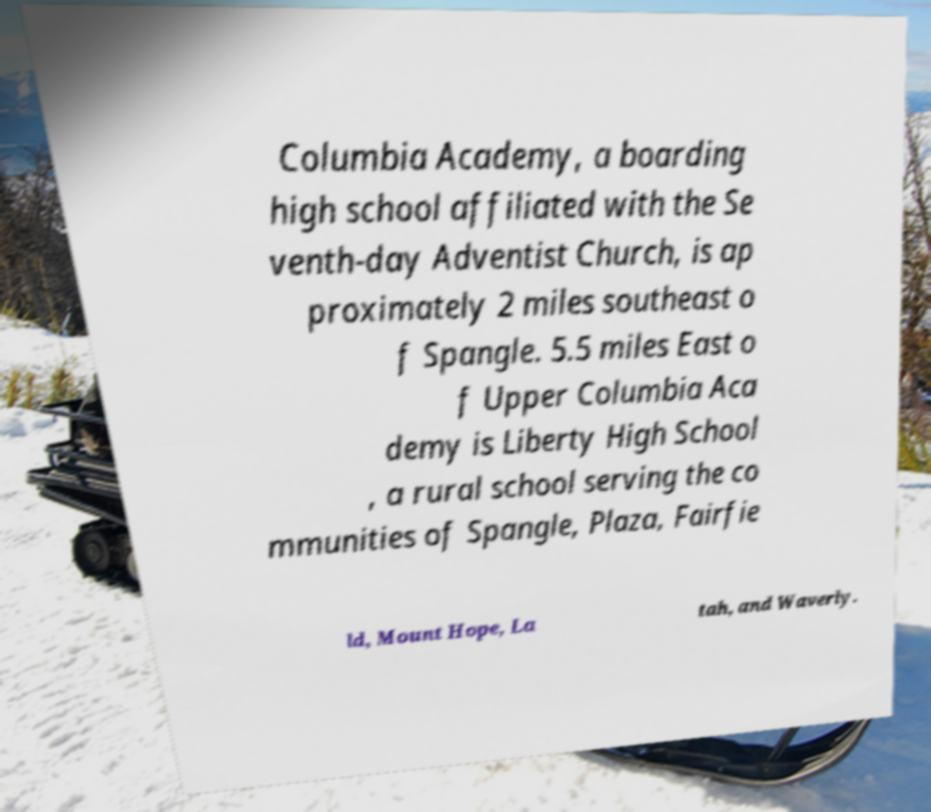What messages or text are displayed in this image? I need them in a readable, typed format. Columbia Academy, a boarding high school affiliated with the Se venth-day Adventist Church, is ap proximately 2 miles southeast o f Spangle. 5.5 miles East o f Upper Columbia Aca demy is Liberty High School , a rural school serving the co mmunities of Spangle, Plaza, Fairfie ld, Mount Hope, La tah, and Waverly. 